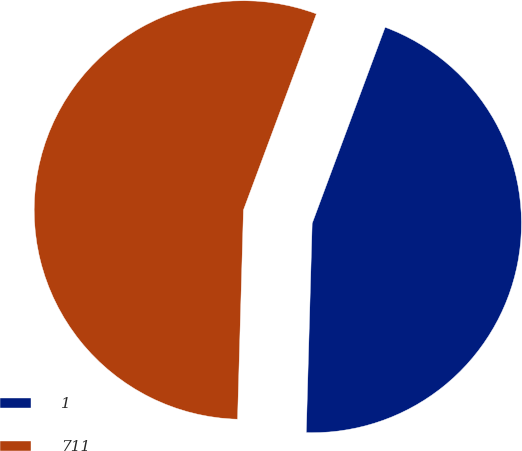Convert chart to OTSL. <chart><loc_0><loc_0><loc_500><loc_500><pie_chart><fcel>1<fcel>711<nl><fcel>44.78%<fcel>55.22%<nl></chart> 